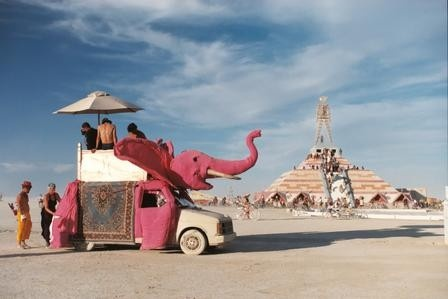Describe the objects in this image and their specific colors. I can see truck in blue, brown, gray, salmon, and maroon tones, umbrella in blue, darkgray, gray, lightgray, and tan tones, people in blue, maroon, brown, gray, and tan tones, people in blue, black, darkgray, maroon, and brown tones, and people in blue, brown, black, tan, and maroon tones in this image. 